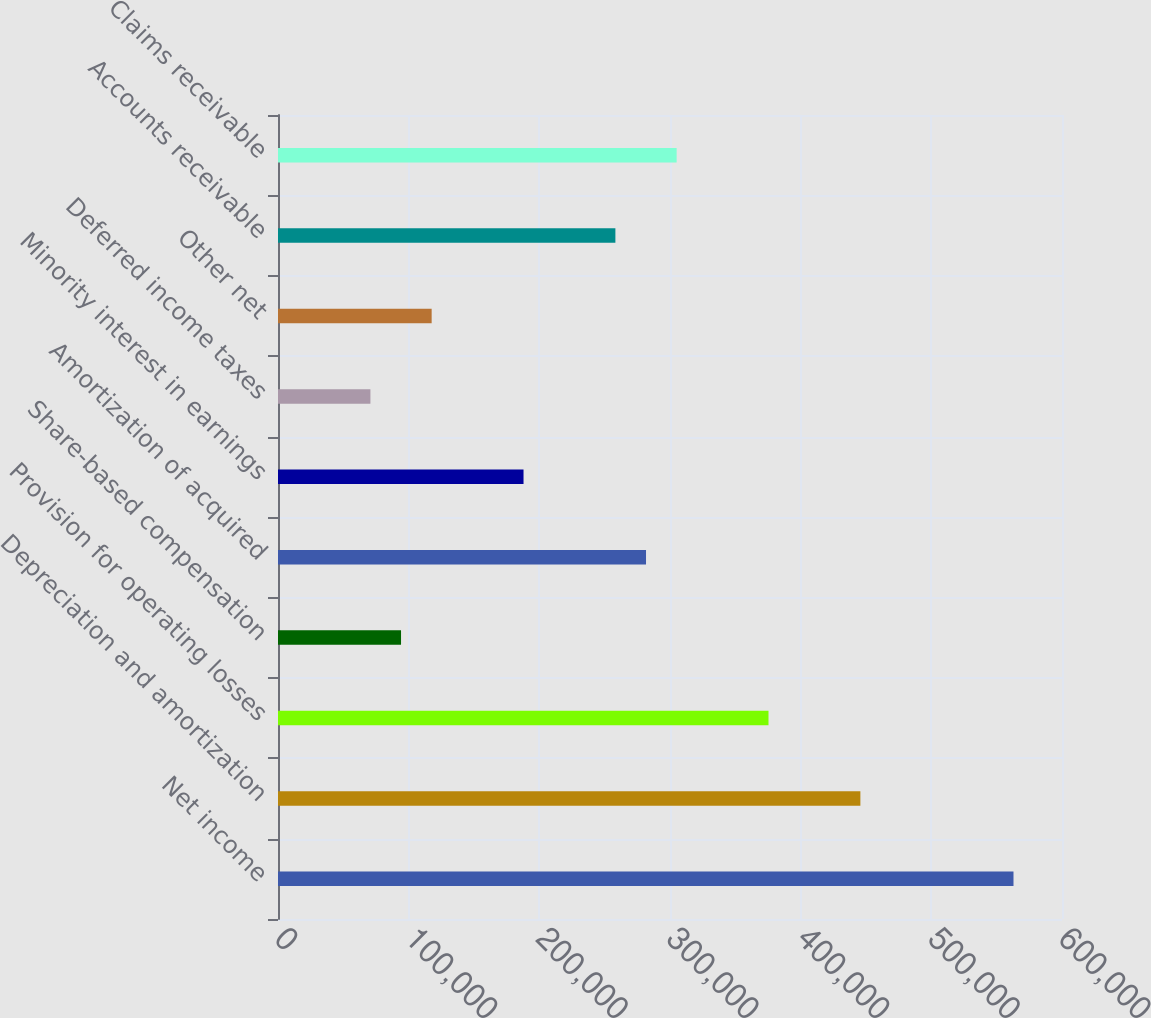Convert chart. <chart><loc_0><loc_0><loc_500><loc_500><bar_chart><fcel>Net income<fcel>Depreciation and amortization<fcel>Provision for operating losses<fcel>Share-based compensation<fcel>Amortization of acquired<fcel>Minority interest in earnings<fcel>Deferred income taxes<fcel>Other net<fcel>Accounts receivable<fcel>Claims receivable<nl><fcel>562874<fcel>445695<fcel>375388<fcel>94158.2<fcel>281645<fcel>187901<fcel>70722.4<fcel>117594<fcel>258209<fcel>305080<nl></chart> 